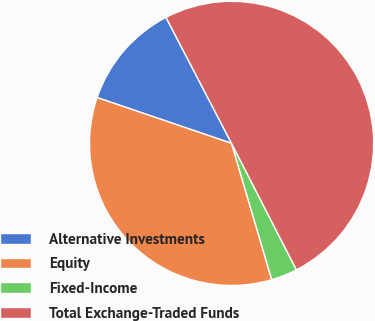<chart> <loc_0><loc_0><loc_500><loc_500><pie_chart><fcel>Alternative Investments<fcel>Equity<fcel>Fixed-Income<fcel>Total Exchange-Traded Funds<nl><fcel>12.13%<fcel>34.79%<fcel>2.98%<fcel>50.1%<nl></chart> 